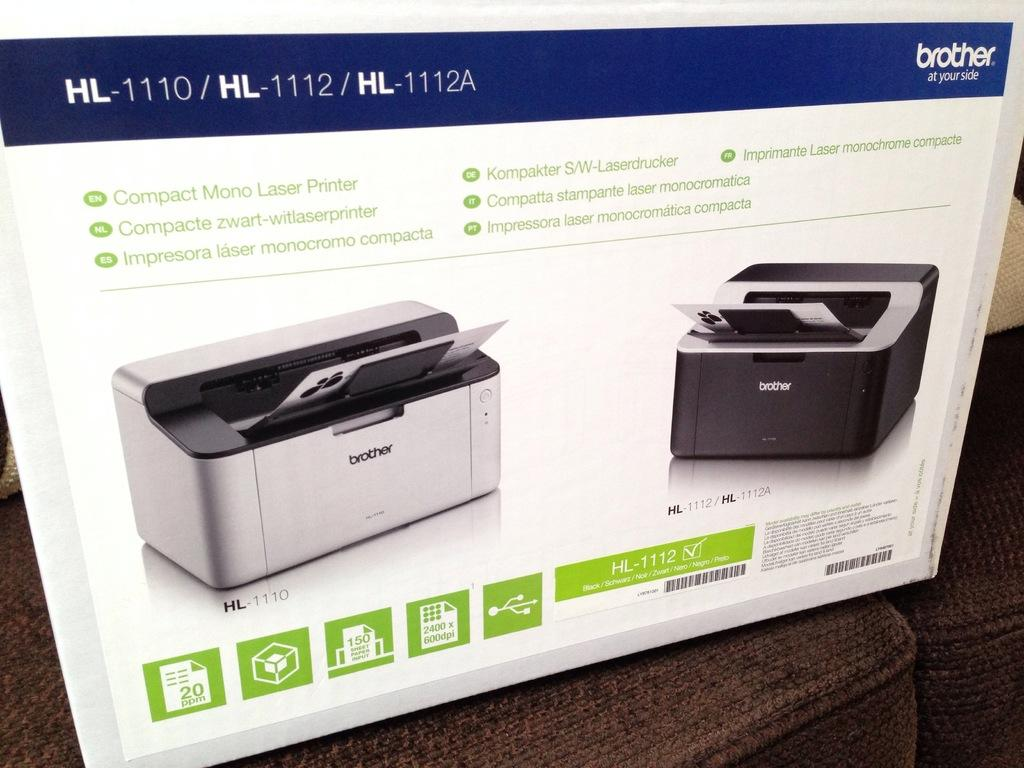<image>
Give a short and clear explanation of the subsequent image. A box containing a brother HL printer sits on a sofa cushion 